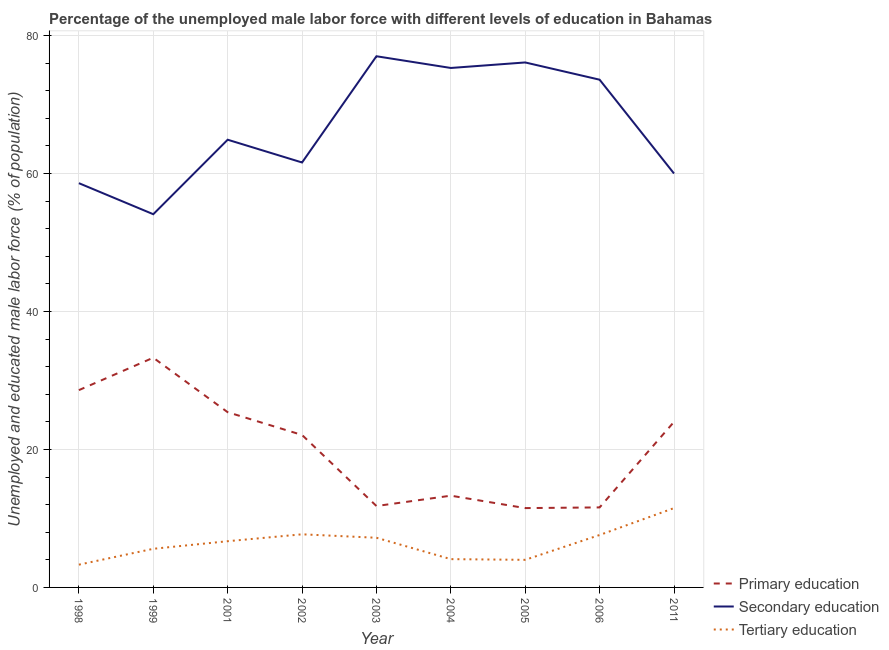How many different coloured lines are there?
Make the answer very short. 3. Does the line corresponding to percentage of male labor force who received secondary education intersect with the line corresponding to percentage of male labor force who received tertiary education?
Make the answer very short. No. Is the number of lines equal to the number of legend labels?
Provide a short and direct response. Yes. What is the percentage of male labor force who received tertiary education in 1998?
Ensure brevity in your answer.  3.3. Across all years, what is the minimum percentage of male labor force who received secondary education?
Your answer should be very brief. 54.1. In which year was the percentage of male labor force who received primary education maximum?
Your answer should be very brief. 1999. What is the total percentage of male labor force who received tertiary education in the graph?
Offer a very short reply. 57.7. What is the difference between the percentage of male labor force who received primary education in 2001 and that in 2002?
Ensure brevity in your answer.  3.3. What is the difference between the percentage of male labor force who received tertiary education in 2003 and the percentage of male labor force who received primary education in 1998?
Your response must be concise. -21.4. What is the average percentage of male labor force who received primary education per year?
Offer a very short reply. 20.18. In the year 2006, what is the difference between the percentage of male labor force who received tertiary education and percentage of male labor force who received secondary education?
Keep it short and to the point. -66. What is the ratio of the percentage of male labor force who received secondary education in 1999 to that in 2003?
Offer a very short reply. 0.7. What is the difference between the highest and the second highest percentage of male labor force who received secondary education?
Provide a succinct answer. 0.9. What is the difference between the highest and the lowest percentage of male labor force who received tertiary education?
Your answer should be very brief. 8.2. In how many years, is the percentage of male labor force who received secondary education greater than the average percentage of male labor force who received secondary education taken over all years?
Your answer should be very brief. 4. Is the sum of the percentage of male labor force who received primary education in 2004 and 2005 greater than the maximum percentage of male labor force who received tertiary education across all years?
Provide a succinct answer. Yes. Is it the case that in every year, the sum of the percentage of male labor force who received primary education and percentage of male labor force who received secondary education is greater than the percentage of male labor force who received tertiary education?
Offer a terse response. Yes. Does the percentage of male labor force who received secondary education monotonically increase over the years?
Provide a succinct answer. No. Is the percentage of male labor force who received tertiary education strictly less than the percentage of male labor force who received secondary education over the years?
Offer a very short reply. Yes. How many lines are there?
Provide a short and direct response. 3. How many years are there in the graph?
Give a very brief answer. 9. Are the values on the major ticks of Y-axis written in scientific E-notation?
Provide a short and direct response. No. Does the graph contain grids?
Give a very brief answer. Yes. Where does the legend appear in the graph?
Offer a terse response. Bottom right. How many legend labels are there?
Keep it short and to the point. 3. How are the legend labels stacked?
Offer a very short reply. Vertical. What is the title of the graph?
Offer a terse response. Percentage of the unemployed male labor force with different levels of education in Bahamas. What is the label or title of the Y-axis?
Keep it short and to the point. Unemployed and educated male labor force (% of population). What is the Unemployed and educated male labor force (% of population) in Primary education in 1998?
Provide a succinct answer. 28.6. What is the Unemployed and educated male labor force (% of population) in Secondary education in 1998?
Your answer should be compact. 58.6. What is the Unemployed and educated male labor force (% of population) of Tertiary education in 1998?
Your response must be concise. 3.3. What is the Unemployed and educated male labor force (% of population) in Primary education in 1999?
Your answer should be very brief. 33.3. What is the Unemployed and educated male labor force (% of population) of Secondary education in 1999?
Give a very brief answer. 54.1. What is the Unemployed and educated male labor force (% of population) of Tertiary education in 1999?
Your answer should be very brief. 5.6. What is the Unemployed and educated male labor force (% of population) in Primary education in 2001?
Keep it short and to the point. 25.4. What is the Unemployed and educated male labor force (% of population) of Secondary education in 2001?
Offer a terse response. 64.9. What is the Unemployed and educated male labor force (% of population) in Tertiary education in 2001?
Offer a very short reply. 6.7. What is the Unemployed and educated male labor force (% of population) in Primary education in 2002?
Your answer should be very brief. 22.1. What is the Unemployed and educated male labor force (% of population) in Secondary education in 2002?
Keep it short and to the point. 61.6. What is the Unemployed and educated male labor force (% of population) in Tertiary education in 2002?
Keep it short and to the point. 7.7. What is the Unemployed and educated male labor force (% of population) of Primary education in 2003?
Ensure brevity in your answer.  11.8. What is the Unemployed and educated male labor force (% of population) in Tertiary education in 2003?
Keep it short and to the point. 7.2. What is the Unemployed and educated male labor force (% of population) of Primary education in 2004?
Offer a very short reply. 13.3. What is the Unemployed and educated male labor force (% of population) in Secondary education in 2004?
Keep it short and to the point. 75.3. What is the Unemployed and educated male labor force (% of population) in Tertiary education in 2004?
Offer a terse response. 4.1. What is the Unemployed and educated male labor force (% of population) in Secondary education in 2005?
Your response must be concise. 76.1. What is the Unemployed and educated male labor force (% of population) in Tertiary education in 2005?
Make the answer very short. 4. What is the Unemployed and educated male labor force (% of population) in Primary education in 2006?
Make the answer very short. 11.6. What is the Unemployed and educated male labor force (% of population) of Secondary education in 2006?
Offer a very short reply. 73.6. What is the Unemployed and educated male labor force (% of population) in Tertiary education in 2006?
Give a very brief answer. 7.6. What is the Unemployed and educated male labor force (% of population) of Primary education in 2011?
Offer a terse response. 24. What is the Unemployed and educated male labor force (% of population) of Secondary education in 2011?
Your response must be concise. 60. What is the Unemployed and educated male labor force (% of population) in Tertiary education in 2011?
Ensure brevity in your answer.  11.5. Across all years, what is the maximum Unemployed and educated male labor force (% of population) in Primary education?
Provide a succinct answer. 33.3. Across all years, what is the minimum Unemployed and educated male labor force (% of population) of Secondary education?
Provide a short and direct response. 54.1. Across all years, what is the minimum Unemployed and educated male labor force (% of population) of Tertiary education?
Give a very brief answer. 3.3. What is the total Unemployed and educated male labor force (% of population) of Primary education in the graph?
Your answer should be compact. 181.6. What is the total Unemployed and educated male labor force (% of population) of Secondary education in the graph?
Keep it short and to the point. 601.2. What is the total Unemployed and educated male labor force (% of population) in Tertiary education in the graph?
Provide a succinct answer. 57.7. What is the difference between the Unemployed and educated male labor force (% of population) of Tertiary education in 1998 and that in 1999?
Your answer should be very brief. -2.3. What is the difference between the Unemployed and educated male labor force (% of population) in Primary education in 1998 and that in 2001?
Ensure brevity in your answer.  3.2. What is the difference between the Unemployed and educated male labor force (% of population) in Secondary education in 1998 and that in 2001?
Offer a very short reply. -6.3. What is the difference between the Unemployed and educated male labor force (% of population) in Primary education in 1998 and that in 2002?
Provide a succinct answer. 6.5. What is the difference between the Unemployed and educated male labor force (% of population) in Primary education in 1998 and that in 2003?
Provide a succinct answer. 16.8. What is the difference between the Unemployed and educated male labor force (% of population) in Secondary education in 1998 and that in 2003?
Give a very brief answer. -18.4. What is the difference between the Unemployed and educated male labor force (% of population) in Tertiary education in 1998 and that in 2003?
Give a very brief answer. -3.9. What is the difference between the Unemployed and educated male labor force (% of population) in Primary education in 1998 and that in 2004?
Your response must be concise. 15.3. What is the difference between the Unemployed and educated male labor force (% of population) in Secondary education in 1998 and that in 2004?
Ensure brevity in your answer.  -16.7. What is the difference between the Unemployed and educated male labor force (% of population) of Secondary education in 1998 and that in 2005?
Your response must be concise. -17.5. What is the difference between the Unemployed and educated male labor force (% of population) in Tertiary education in 1998 and that in 2006?
Your answer should be compact. -4.3. What is the difference between the Unemployed and educated male labor force (% of population) of Secondary education in 1998 and that in 2011?
Provide a succinct answer. -1.4. What is the difference between the Unemployed and educated male labor force (% of population) of Tertiary education in 1998 and that in 2011?
Your answer should be very brief. -8.2. What is the difference between the Unemployed and educated male labor force (% of population) of Secondary education in 1999 and that in 2001?
Provide a succinct answer. -10.8. What is the difference between the Unemployed and educated male labor force (% of population) of Tertiary education in 1999 and that in 2001?
Your answer should be compact. -1.1. What is the difference between the Unemployed and educated male labor force (% of population) of Tertiary education in 1999 and that in 2002?
Make the answer very short. -2.1. What is the difference between the Unemployed and educated male labor force (% of population) of Secondary education in 1999 and that in 2003?
Your answer should be very brief. -22.9. What is the difference between the Unemployed and educated male labor force (% of population) in Tertiary education in 1999 and that in 2003?
Offer a terse response. -1.6. What is the difference between the Unemployed and educated male labor force (% of population) of Primary education in 1999 and that in 2004?
Give a very brief answer. 20. What is the difference between the Unemployed and educated male labor force (% of population) in Secondary education in 1999 and that in 2004?
Your answer should be very brief. -21.2. What is the difference between the Unemployed and educated male labor force (% of population) in Primary education in 1999 and that in 2005?
Your answer should be compact. 21.8. What is the difference between the Unemployed and educated male labor force (% of population) of Secondary education in 1999 and that in 2005?
Make the answer very short. -22. What is the difference between the Unemployed and educated male labor force (% of population) of Tertiary education in 1999 and that in 2005?
Offer a terse response. 1.6. What is the difference between the Unemployed and educated male labor force (% of population) in Primary education in 1999 and that in 2006?
Keep it short and to the point. 21.7. What is the difference between the Unemployed and educated male labor force (% of population) of Secondary education in 1999 and that in 2006?
Your answer should be compact. -19.5. What is the difference between the Unemployed and educated male labor force (% of population) of Secondary education in 1999 and that in 2011?
Make the answer very short. -5.9. What is the difference between the Unemployed and educated male labor force (% of population) in Primary education in 2001 and that in 2002?
Keep it short and to the point. 3.3. What is the difference between the Unemployed and educated male labor force (% of population) of Secondary education in 2001 and that in 2002?
Make the answer very short. 3.3. What is the difference between the Unemployed and educated male labor force (% of population) in Tertiary education in 2001 and that in 2002?
Offer a terse response. -1. What is the difference between the Unemployed and educated male labor force (% of population) in Tertiary education in 2001 and that in 2003?
Offer a terse response. -0.5. What is the difference between the Unemployed and educated male labor force (% of population) in Secondary education in 2001 and that in 2005?
Give a very brief answer. -11.2. What is the difference between the Unemployed and educated male labor force (% of population) of Primary education in 2001 and that in 2006?
Ensure brevity in your answer.  13.8. What is the difference between the Unemployed and educated male labor force (% of population) of Secondary education in 2001 and that in 2006?
Offer a terse response. -8.7. What is the difference between the Unemployed and educated male labor force (% of population) of Primary education in 2001 and that in 2011?
Give a very brief answer. 1.4. What is the difference between the Unemployed and educated male labor force (% of population) in Tertiary education in 2001 and that in 2011?
Ensure brevity in your answer.  -4.8. What is the difference between the Unemployed and educated male labor force (% of population) in Primary education in 2002 and that in 2003?
Ensure brevity in your answer.  10.3. What is the difference between the Unemployed and educated male labor force (% of population) in Secondary education in 2002 and that in 2003?
Offer a very short reply. -15.4. What is the difference between the Unemployed and educated male labor force (% of population) of Secondary education in 2002 and that in 2004?
Make the answer very short. -13.7. What is the difference between the Unemployed and educated male labor force (% of population) of Tertiary education in 2002 and that in 2004?
Your response must be concise. 3.6. What is the difference between the Unemployed and educated male labor force (% of population) in Primary education in 2002 and that in 2005?
Offer a terse response. 10.6. What is the difference between the Unemployed and educated male labor force (% of population) of Tertiary education in 2002 and that in 2005?
Your response must be concise. 3.7. What is the difference between the Unemployed and educated male labor force (% of population) in Primary education in 2002 and that in 2011?
Your answer should be very brief. -1.9. What is the difference between the Unemployed and educated male labor force (% of population) in Tertiary education in 2002 and that in 2011?
Your answer should be very brief. -3.8. What is the difference between the Unemployed and educated male labor force (% of population) of Tertiary education in 2003 and that in 2004?
Offer a very short reply. 3.1. What is the difference between the Unemployed and educated male labor force (% of population) of Primary education in 2003 and that in 2005?
Your response must be concise. 0.3. What is the difference between the Unemployed and educated male labor force (% of population) of Secondary education in 2003 and that in 2005?
Provide a succinct answer. 0.9. What is the difference between the Unemployed and educated male labor force (% of population) of Tertiary education in 2003 and that in 2005?
Provide a short and direct response. 3.2. What is the difference between the Unemployed and educated male labor force (% of population) in Primary education in 2003 and that in 2011?
Provide a short and direct response. -12.2. What is the difference between the Unemployed and educated male labor force (% of population) in Primary education in 2004 and that in 2005?
Offer a very short reply. 1.8. What is the difference between the Unemployed and educated male labor force (% of population) in Secondary education in 2004 and that in 2005?
Your answer should be compact. -0.8. What is the difference between the Unemployed and educated male labor force (% of population) of Tertiary education in 2004 and that in 2005?
Keep it short and to the point. 0.1. What is the difference between the Unemployed and educated male labor force (% of population) of Secondary education in 2004 and that in 2006?
Provide a short and direct response. 1.7. What is the difference between the Unemployed and educated male labor force (% of population) in Tertiary education in 2004 and that in 2006?
Offer a terse response. -3.5. What is the difference between the Unemployed and educated male labor force (% of population) in Secondary education in 2004 and that in 2011?
Your answer should be very brief. 15.3. What is the difference between the Unemployed and educated male labor force (% of population) in Tertiary education in 2004 and that in 2011?
Provide a short and direct response. -7.4. What is the difference between the Unemployed and educated male labor force (% of population) of Primary education in 2005 and that in 2006?
Offer a very short reply. -0.1. What is the difference between the Unemployed and educated male labor force (% of population) of Tertiary education in 2005 and that in 2006?
Your response must be concise. -3.6. What is the difference between the Unemployed and educated male labor force (% of population) in Secondary education in 2006 and that in 2011?
Your answer should be compact. 13.6. What is the difference between the Unemployed and educated male labor force (% of population) of Tertiary education in 2006 and that in 2011?
Your answer should be compact. -3.9. What is the difference between the Unemployed and educated male labor force (% of population) of Primary education in 1998 and the Unemployed and educated male labor force (% of population) of Secondary education in 1999?
Keep it short and to the point. -25.5. What is the difference between the Unemployed and educated male labor force (% of population) in Primary education in 1998 and the Unemployed and educated male labor force (% of population) in Secondary education in 2001?
Make the answer very short. -36.3. What is the difference between the Unemployed and educated male labor force (% of population) in Primary education in 1998 and the Unemployed and educated male labor force (% of population) in Tertiary education in 2001?
Your answer should be compact. 21.9. What is the difference between the Unemployed and educated male labor force (% of population) in Secondary education in 1998 and the Unemployed and educated male labor force (% of population) in Tertiary education in 2001?
Offer a terse response. 51.9. What is the difference between the Unemployed and educated male labor force (% of population) of Primary education in 1998 and the Unemployed and educated male labor force (% of population) of Secondary education in 2002?
Provide a succinct answer. -33. What is the difference between the Unemployed and educated male labor force (% of population) in Primary education in 1998 and the Unemployed and educated male labor force (% of population) in Tertiary education in 2002?
Ensure brevity in your answer.  20.9. What is the difference between the Unemployed and educated male labor force (% of population) of Secondary education in 1998 and the Unemployed and educated male labor force (% of population) of Tertiary education in 2002?
Ensure brevity in your answer.  50.9. What is the difference between the Unemployed and educated male labor force (% of population) in Primary education in 1998 and the Unemployed and educated male labor force (% of population) in Secondary education in 2003?
Provide a short and direct response. -48.4. What is the difference between the Unemployed and educated male labor force (% of population) of Primary education in 1998 and the Unemployed and educated male labor force (% of population) of Tertiary education in 2003?
Ensure brevity in your answer.  21.4. What is the difference between the Unemployed and educated male labor force (% of population) of Secondary education in 1998 and the Unemployed and educated male labor force (% of population) of Tertiary education in 2003?
Your answer should be very brief. 51.4. What is the difference between the Unemployed and educated male labor force (% of population) of Primary education in 1998 and the Unemployed and educated male labor force (% of population) of Secondary education in 2004?
Your answer should be compact. -46.7. What is the difference between the Unemployed and educated male labor force (% of population) of Primary education in 1998 and the Unemployed and educated male labor force (% of population) of Tertiary education in 2004?
Keep it short and to the point. 24.5. What is the difference between the Unemployed and educated male labor force (% of population) of Secondary education in 1998 and the Unemployed and educated male labor force (% of population) of Tertiary education in 2004?
Offer a very short reply. 54.5. What is the difference between the Unemployed and educated male labor force (% of population) of Primary education in 1998 and the Unemployed and educated male labor force (% of population) of Secondary education in 2005?
Your answer should be compact. -47.5. What is the difference between the Unemployed and educated male labor force (% of population) of Primary education in 1998 and the Unemployed and educated male labor force (% of population) of Tertiary education in 2005?
Your response must be concise. 24.6. What is the difference between the Unemployed and educated male labor force (% of population) of Secondary education in 1998 and the Unemployed and educated male labor force (% of population) of Tertiary education in 2005?
Your response must be concise. 54.6. What is the difference between the Unemployed and educated male labor force (% of population) of Primary education in 1998 and the Unemployed and educated male labor force (% of population) of Secondary education in 2006?
Provide a short and direct response. -45. What is the difference between the Unemployed and educated male labor force (% of population) of Secondary education in 1998 and the Unemployed and educated male labor force (% of population) of Tertiary education in 2006?
Make the answer very short. 51. What is the difference between the Unemployed and educated male labor force (% of population) of Primary education in 1998 and the Unemployed and educated male labor force (% of population) of Secondary education in 2011?
Provide a succinct answer. -31.4. What is the difference between the Unemployed and educated male labor force (% of population) in Secondary education in 1998 and the Unemployed and educated male labor force (% of population) in Tertiary education in 2011?
Keep it short and to the point. 47.1. What is the difference between the Unemployed and educated male labor force (% of population) in Primary education in 1999 and the Unemployed and educated male labor force (% of population) in Secondary education in 2001?
Make the answer very short. -31.6. What is the difference between the Unemployed and educated male labor force (% of population) of Primary education in 1999 and the Unemployed and educated male labor force (% of population) of Tertiary education in 2001?
Offer a very short reply. 26.6. What is the difference between the Unemployed and educated male labor force (% of population) in Secondary education in 1999 and the Unemployed and educated male labor force (% of population) in Tertiary education in 2001?
Your response must be concise. 47.4. What is the difference between the Unemployed and educated male labor force (% of population) in Primary education in 1999 and the Unemployed and educated male labor force (% of population) in Secondary education in 2002?
Provide a short and direct response. -28.3. What is the difference between the Unemployed and educated male labor force (% of population) of Primary education in 1999 and the Unemployed and educated male labor force (% of population) of Tertiary education in 2002?
Provide a short and direct response. 25.6. What is the difference between the Unemployed and educated male labor force (% of population) in Secondary education in 1999 and the Unemployed and educated male labor force (% of population) in Tertiary education in 2002?
Keep it short and to the point. 46.4. What is the difference between the Unemployed and educated male labor force (% of population) in Primary education in 1999 and the Unemployed and educated male labor force (% of population) in Secondary education in 2003?
Offer a terse response. -43.7. What is the difference between the Unemployed and educated male labor force (% of population) of Primary education in 1999 and the Unemployed and educated male labor force (% of population) of Tertiary education in 2003?
Ensure brevity in your answer.  26.1. What is the difference between the Unemployed and educated male labor force (% of population) in Secondary education in 1999 and the Unemployed and educated male labor force (% of population) in Tertiary education in 2003?
Offer a terse response. 46.9. What is the difference between the Unemployed and educated male labor force (% of population) of Primary education in 1999 and the Unemployed and educated male labor force (% of population) of Secondary education in 2004?
Keep it short and to the point. -42. What is the difference between the Unemployed and educated male labor force (% of population) of Primary education in 1999 and the Unemployed and educated male labor force (% of population) of Tertiary education in 2004?
Give a very brief answer. 29.2. What is the difference between the Unemployed and educated male labor force (% of population) in Secondary education in 1999 and the Unemployed and educated male labor force (% of population) in Tertiary education in 2004?
Your answer should be very brief. 50. What is the difference between the Unemployed and educated male labor force (% of population) of Primary education in 1999 and the Unemployed and educated male labor force (% of population) of Secondary education in 2005?
Your response must be concise. -42.8. What is the difference between the Unemployed and educated male labor force (% of population) in Primary education in 1999 and the Unemployed and educated male labor force (% of population) in Tertiary education in 2005?
Your answer should be very brief. 29.3. What is the difference between the Unemployed and educated male labor force (% of population) of Secondary education in 1999 and the Unemployed and educated male labor force (% of population) of Tertiary education in 2005?
Your response must be concise. 50.1. What is the difference between the Unemployed and educated male labor force (% of population) in Primary education in 1999 and the Unemployed and educated male labor force (% of population) in Secondary education in 2006?
Your response must be concise. -40.3. What is the difference between the Unemployed and educated male labor force (% of population) of Primary education in 1999 and the Unemployed and educated male labor force (% of population) of Tertiary education in 2006?
Your answer should be very brief. 25.7. What is the difference between the Unemployed and educated male labor force (% of population) of Secondary education in 1999 and the Unemployed and educated male labor force (% of population) of Tertiary education in 2006?
Keep it short and to the point. 46.5. What is the difference between the Unemployed and educated male labor force (% of population) of Primary education in 1999 and the Unemployed and educated male labor force (% of population) of Secondary education in 2011?
Give a very brief answer. -26.7. What is the difference between the Unemployed and educated male labor force (% of population) in Primary education in 1999 and the Unemployed and educated male labor force (% of population) in Tertiary education in 2011?
Your response must be concise. 21.8. What is the difference between the Unemployed and educated male labor force (% of population) in Secondary education in 1999 and the Unemployed and educated male labor force (% of population) in Tertiary education in 2011?
Provide a succinct answer. 42.6. What is the difference between the Unemployed and educated male labor force (% of population) in Primary education in 2001 and the Unemployed and educated male labor force (% of population) in Secondary education in 2002?
Provide a succinct answer. -36.2. What is the difference between the Unemployed and educated male labor force (% of population) in Primary education in 2001 and the Unemployed and educated male labor force (% of population) in Tertiary education in 2002?
Your response must be concise. 17.7. What is the difference between the Unemployed and educated male labor force (% of population) of Secondary education in 2001 and the Unemployed and educated male labor force (% of population) of Tertiary education in 2002?
Provide a short and direct response. 57.2. What is the difference between the Unemployed and educated male labor force (% of population) in Primary education in 2001 and the Unemployed and educated male labor force (% of population) in Secondary education in 2003?
Your answer should be compact. -51.6. What is the difference between the Unemployed and educated male labor force (% of population) in Primary education in 2001 and the Unemployed and educated male labor force (% of population) in Tertiary education in 2003?
Your answer should be very brief. 18.2. What is the difference between the Unemployed and educated male labor force (% of population) in Secondary education in 2001 and the Unemployed and educated male labor force (% of population) in Tertiary education in 2003?
Your answer should be compact. 57.7. What is the difference between the Unemployed and educated male labor force (% of population) in Primary education in 2001 and the Unemployed and educated male labor force (% of population) in Secondary education in 2004?
Ensure brevity in your answer.  -49.9. What is the difference between the Unemployed and educated male labor force (% of population) in Primary education in 2001 and the Unemployed and educated male labor force (% of population) in Tertiary education in 2004?
Your response must be concise. 21.3. What is the difference between the Unemployed and educated male labor force (% of population) of Secondary education in 2001 and the Unemployed and educated male labor force (% of population) of Tertiary education in 2004?
Give a very brief answer. 60.8. What is the difference between the Unemployed and educated male labor force (% of population) in Primary education in 2001 and the Unemployed and educated male labor force (% of population) in Secondary education in 2005?
Provide a short and direct response. -50.7. What is the difference between the Unemployed and educated male labor force (% of population) in Primary education in 2001 and the Unemployed and educated male labor force (% of population) in Tertiary education in 2005?
Make the answer very short. 21.4. What is the difference between the Unemployed and educated male labor force (% of population) in Secondary education in 2001 and the Unemployed and educated male labor force (% of population) in Tertiary education in 2005?
Your answer should be very brief. 60.9. What is the difference between the Unemployed and educated male labor force (% of population) of Primary education in 2001 and the Unemployed and educated male labor force (% of population) of Secondary education in 2006?
Offer a terse response. -48.2. What is the difference between the Unemployed and educated male labor force (% of population) in Secondary education in 2001 and the Unemployed and educated male labor force (% of population) in Tertiary education in 2006?
Offer a very short reply. 57.3. What is the difference between the Unemployed and educated male labor force (% of population) of Primary education in 2001 and the Unemployed and educated male labor force (% of population) of Secondary education in 2011?
Offer a very short reply. -34.6. What is the difference between the Unemployed and educated male labor force (% of population) in Primary education in 2001 and the Unemployed and educated male labor force (% of population) in Tertiary education in 2011?
Give a very brief answer. 13.9. What is the difference between the Unemployed and educated male labor force (% of population) in Secondary education in 2001 and the Unemployed and educated male labor force (% of population) in Tertiary education in 2011?
Provide a short and direct response. 53.4. What is the difference between the Unemployed and educated male labor force (% of population) of Primary education in 2002 and the Unemployed and educated male labor force (% of population) of Secondary education in 2003?
Your answer should be very brief. -54.9. What is the difference between the Unemployed and educated male labor force (% of population) of Primary education in 2002 and the Unemployed and educated male labor force (% of population) of Tertiary education in 2003?
Make the answer very short. 14.9. What is the difference between the Unemployed and educated male labor force (% of population) in Secondary education in 2002 and the Unemployed and educated male labor force (% of population) in Tertiary education in 2003?
Provide a succinct answer. 54.4. What is the difference between the Unemployed and educated male labor force (% of population) of Primary education in 2002 and the Unemployed and educated male labor force (% of population) of Secondary education in 2004?
Your response must be concise. -53.2. What is the difference between the Unemployed and educated male labor force (% of population) of Secondary education in 2002 and the Unemployed and educated male labor force (% of population) of Tertiary education in 2004?
Your answer should be very brief. 57.5. What is the difference between the Unemployed and educated male labor force (% of population) of Primary education in 2002 and the Unemployed and educated male labor force (% of population) of Secondary education in 2005?
Provide a succinct answer. -54. What is the difference between the Unemployed and educated male labor force (% of population) of Primary education in 2002 and the Unemployed and educated male labor force (% of population) of Tertiary education in 2005?
Your answer should be compact. 18.1. What is the difference between the Unemployed and educated male labor force (% of population) of Secondary education in 2002 and the Unemployed and educated male labor force (% of population) of Tertiary education in 2005?
Give a very brief answer. 57.6. What is the difference between the Unemployed and educated male labor force (% of population) in Primary education in 2002 and the Unemployed and educated male labor force (% of population) in Secondary education in 2006?
Ensure brevity in your answer.  -51.5. What is the difference between the Unemployed and educated male labor force (% of population) in Secondary education in 2002 and the Unemployed and educated male labor force (% of population) in Tertiary education in 2006?
Keep it short and to the point. 54. What is the difference between the Unemployed and educated male labor force (% of population) of Primary education in 2002 and the Unemployed and educated male labor force (% of population) of Secondary education in 2011?
Your answer should be compact. -37.9. What is the difference between the Unemployed and educated male labor force (% of population) in Primary education in 2002 and the Unemployed and educated male labor force (% of population) in Tertiary education in 2011?
Ensure brevity in your answer.  10.6. What is the difference between the Unemployed and educated male labor force (% of population) in Secondary education in 2002 and the Unemployed and educated male labor force (% of population) in Tertiary education in 2011?
Your answer should be very brief. 50.1. What is the difference between the Unemployed and educated male labor force (% of population) of Primary education in 2003 and the Unemployed and educated male labor force (% of population) of Secondary education in 2004?
Provide a short and direct response. -63.5. What is the difference between the Unemployed and educated male labor force (% of population) in Primary education in 2003 and the Unemployed and educated male labor force (% of population) in Tertiary education in 2004?
Ensure brevity in your answer.  7.7. What is the difference between the Unemployed and educated male labor force (% of population) in Secondary education in 2003 and the Unemployed and educated male labor force (% of population) in Tertiary education in 2004?
Provide a succinct answer. 72.9. What is the difference between the Unemployed and educated male labor force (% of population) in Primary education in 2003 and the Unemployed and educated male labor force (% of population) in Secondary education in 2005?
Provide a short and direct response. -64.3. What is the difference between the Unemployed and educated male labor force (% of population) of Primary education in 2003 and the Unemployed and educated male labor force (% of population) of Tertiary education in 2005?
Offer a very short reply. 7.8. What is the difference between the Unemployed and educated male labor force (% of population) in Secondary education in 2003 and the Unemployed and educated male labor force (% of population) in Tertiary education in 2005?
Keep it short and to the point. 73. What is the difference between the Unemployed and educated male labor force (% of population) in Primary education in 2003 and the Unemployed and educated male labor force (% of population) in Secondary education in 2006?
Keep it short and to the point. -61.8. What is the difference between the Unemployed and educated male labor force (% of population) in Primary education in 2003 and the Unemployed and educated male labor force (% of population) in Tertiary education in 2006?
Give a very brief answer. 4.2. What is the difference between the Unemployed and educated male labor force (% of population) of Secondary education in 2003 and the Unemployed and educated male labor force (% of population) of Tertiary education in 2006?
Provide a succinct answer. 69.4. What is the difference between the Unemployed and educated male labor force (% of population) of Primary education in 2003 and the Unemployed and educated male labor force (% of population) of Secondary education in 2011?
Your answer should be compact. -48.2. What is the difference between the Unemployed and educated male labor force (% of population) of Primary education in 2003 and the Unemployed and educated male labor force (% of population) of Tertiary education in 2011?
Offer a terse response. 0.3. What is the difference between the Unemployed and educated male labor force (% of population) of Secondary education in 2003 and the Unemployed and educated male labor force (% of population) of Tertiary education in 2011?
Offer a very short reply. 65.5. What is the difference between the Unemployed and educated male labor force (% of population) in Primary education in 2004 and the Unemployed and educated male labor force (% of population) in Secondary education in 2005?
Your answer should be compact. -62.8. What is the difference between the Unemployed and educated male labor force (% of population) of Secondary education in 2004 and the Unemployed and educated male labor force (% of population) of Tertiary education in 2005?
Offer a terse response. 71.3. What is the difference between the Unemployed and educated male labor force (% of population) of Primary education in 2004 and the Unemployed and educated male labor force (% of population) of Secondary education in 2006?
Your answer should be compact. -60.3. What is the difference between the Unemployed and educated male labor force (% of population) in Secondary education in 2004 and the Unemployed and educated male labor force (% of population) in Tertiary education in 2006?
Offer a terse response. 67.7. What is the difference between the Unemployed and educated male labor force (% of population) in Primary education in 2004 and the Unemployed and educated male labor force (% of population) in Secondary education in 2011?
Keep it short and to the point. -46.7. What is the difference between the Unemployed and educated male labor force (% of population) of Primary education in 2004 and the Unemployed and educated male labor force (% of population) of Tertiary education in 2011?
Provide a short and direct response. 1.8. What is the difference between the Unemployed and educated male labor force (% of population) of Secondary education in 2004 and the Unemployed and educated male labor force (% of population) of Tertiary education in 2011?
Provide a short and direct response. 63.8. What is the difference between the Unemployed and educated male labor force (% of population) of Primary education in 2005 and the Unemployed and educated male labor force (% of population) of Secondary education in 2006?
Your response must be concise. -62.1. What is the difference between the Unemployed and educated male labor force (% of population) in Secondary education in 2005 and the Unemployed and educated male labor force (% of population) in Tertiary education in 2006?
Keep it short and to the point. 68.5. What is the difference between the Unemployed and educated male labor force (% of population) of Primary education in 2005 and the Unemployed and educated male labor force (% of population) of Secondary education in 2011?
Provide a succinct answer. -48.5. What is the difference between the Unemployed and educated male labor force (% of population) of Secondary education in 2005 and the Unemployed and educated male labor force (% of population) of Tertiary education in 2011?
Ensure brevity in your answer.  64.6. What is the difference between the Unemployed and educated male labor force (% of population) in Primary education in 2006 and the Unemployed and educated male labor force (% of population) in Secondary education in 2011?
Keep it short and to the point. -48.4. What is the difference between the Unemployed and educated male labor force (% of population) in Secondary education in 2006 and the Unemployed and educated male labor force (% of population) in Tertiary education in 2011?
Your answer should be very brief. 62.1. What is the average Unemployed and educated male labor force (% of population) of Primary education per year?
Keep it short and to the point. 20.18. What is the average Unemployed and educated male labor force (% of population) of Secondary education per year?
Ensure brevity in your answer.  66.8. What is the average Unemployed and educated male labor force (% of population) in Tertiary education per year?
Your answer should be compact. 6.41. In the year 1998, what is the difference between the Unemployed and educated male labor force (% of population) in Primary education and Unemployed and educated male labor force (% of population) in Tertiary education?
Keep it short and to the point. 25.3. In the year 1998, what is the difference between the Unemployed and educated male labor force (% of population) in Secondary education and Unemployed and educated male labor force (% of population) in Tertiary education?
Give a very brief answer. 55.3. In the year 1999, what is the difference between the Unemployed and educated male labor force (% of population) in Primary education and Unemployed and educated male labor force (% of population) in Secondary education?
Provide a succinct answer. -20.8. In the year 1999, what is the difference between the Unemployed and educated male labor force (% of population) of Primary education and Unemployed and educated male labor force (% of population) of Tertiary education?
Provide a succinct answer. 27.7. In the year 1999, what is the difference between the Unemployed and educated male labor force (% of population) in Secondary education and Unemployed and educated male labor force (% of population) in Tertiary education?
Keep it short and to the point. 48.5. In the year 2001, what is the difference between the Unemployed and educated male labor force (% of population) of Primary education and Unemployed and educated male labor force (% of population) of Secondary education?
Make the answer very short. -39.5. In the year 2001, what is the difference between the Unemployed and educated male labor force (% of population) in Primary education and Unemployed and educated male labor force (% of population) in Tertiary education?
Keep it short and to the point. 18.7. In the year 2001, what is the difference between the Unemployed and educated male labor force (% of population) of Secondary education and Unemployed and educated male labor force (% of population) of Tertiary education?
Provide a succinct answer. 58.2. In the year 2002, what is the difference between the Unemployed and educated male labor force (% of population) of Primary education and Unemployed and educated male labor force (% of population) of Secondary education?
Ensure brevity in your answer.  -39.5. In the year 2002, what is the difference between the Unemployed and educated male labor force (% of population) in Secondary education and Unemployed and educated male labor force (% of population) in Tertiary education?
Give a very brief answer. 53.9. In the year 2003, what is the difference between the Unemployed and educated male labor force (% of population) in Primary education and Unemployed and educated male labor force (% of population) in Secondary education?
Provide a succinct answer. -65.2. In the year 2003, what is the difference between the Unemployed and educated male labor force (% of population) in Primary education and Unemployed and educated male labor force (% of population) in Tertiary education?
Ensure brevity in your answer.  4.6. In the year 2003, what is the difference between the Unemployed and educated male labor force (% of population) of Secondary education and Unemployed and educated male labor force (% of population) of Tertiary education?
Offer a very short reply. 69.8. In the year 2004, what is the difference between the Unemployed and educated male labor force (% of population) of Primary education and Unemployed and educated male labor force (% of population) of Secondary education?
Ensure brevity in your answer.  -62. In the year 2004, what is the difference between the Unemployed and educated male labor force (% of population) of Primary education and Unemployed and educated male labor force (% of population) of Tertiary education?
Your answer should be very brief. 9.2. In the year 2004, what is the difference between the Unemployed and educated male labor force (% of population) in Secondary education and Unemployed and educated male labor force (% of population) in Tertiary education?
Provide a short and direct response. 71.2. In the year 2005, what is the difference between the Unemployed and educated male labor force (% of population) of Primary education and Unemployed and educated male labor force (% of population) of Secondary education?
Your answer should be compact. -64.6. In the year 2005, what is the difference between the Unemployed and educated male labor force (% of population) in Primary education and Unemployed and educated male labor force (% of population) in Tertiary education?
Offer a very short reply. 7.5. In the year 2005, what is the difference between the Unemployed and educated male labor force (% of population) of Secondary education and Unemployed and educated male labor force (% of population) of Tertiary education?
Your answer should be compact. 72.1. In the year 2006, what is the difference between the Unemployed and educated male labor force (% of population) of Primary education and Unemployed and educated male labor force (% of population) of Secondary education?
Your answer should be very brief. -62. In the year 2011, what is the difference between the Unemployed and educated male labor force (% of population) in Primary education and Unemployed and educated male labor force (% of population) in Secondary education?
Offer a very short reply. -36. In the year 2011, what is the difference between the Unemployed and educated male labor force (% of population) in Secondary education and Unemployed and educated male labor force (% of population) in Tertiary education?
Offer a terse response. 48.5. What is the ratio of the Unemployed and educated male labor force (% of population) in Primary education in 1998 to that in 1999?
Your response must be concise. 0.86. What is the ratio of the Unemployed and educated male labor force (% of population) of Secondary education in 1998 to that in 1999?
Provide a short and direct response. 1.08. What is the ratio of the Unemployed and educated male labor force (% of population) in Tertiary education in 1998 to that in 1999?
Provide a short and direct response. 0.59. What is the ratio of the Unemployed and educated male labor force (% of population) in Primary education in 1998 to that in 2001?
Make the answer very short. 1.13. What is the ratio of the Unemployed and educated male labor force (% of population) in Secondary education in 1998 to that in 2001?
Your answer should be compact. 0.9. What is the ratio of the Unemployed and educated male labor force (% of population) in Tertiary education in 1998 to that in 2001?
Offer a very short reply. 0.49. What is the ratio of the Unemployed and educated male labor force (% of population) of Primary education in 1998 to that in 2002?
Provide a succinct answer. 1.29. What is the ratio of the Unemployed and educated male labor force (% of population) in Secondary education in 1998 to that in 2002?
Offer a terse response. 0.95. What is the ratio of the Unemployed and educated male labor force (% of population) of Tertiary education in 1998 to that in 2002?
Your answer should be compact. 0.43. What is the ratio of the Unemployed and educated male labor force (% of population) of Primary education in 1998 to that in 2003?
Offer a terse response. 2.42. What is the ratio of the Unemployed and educated male labor force (% of population) in Secondary education in 1998 to that in 2003?
Your response must be concise. 0.76. What is the ratio of the Unemployed and educated male labor force (% of population) in Tertiary education in 1998 to that in 2003?
Your answer should be very brief. 0.46. What is the ratio of the Unemployed and educated male labor force (% of population) in Primary education in 1998 to that in 2004?
Make the answer very short. 2.15. What is the ratio of the Unemployed and educated male labor force (% of population) of Secondary education in 1998 to that in 2004?
Your answer should be very brief. 0.78. What is the ratio of the Unemployed and educated male labor force (% of population) of Tertiary education in 1998 to that in 2004?
Provide a short and direct response. 0.8. What is the ratio of the Unemployed and educated male labor force (% of population) in Primary education in 1998 to that in 2005?
Give a very brief answer. 2.49. What is the ratio of the Unemployed and educated male labor force (% of population) in Secondary education in 1998 to that in 2005?
Ensure brevity in your answer.  0.77. What is the ratio of the Unemployed and educated male labor force (% of population) in Tertiary education in 1998 to that in 2005?
Offer a terse response. 0.82. What is the ratio of the Unemployed and educated male labor force (% of population) in Primary education in 1998 to that in 2006?
Ensure brevity in your answer.  2.47. What is the ratio of the Unemployed and educated male labor force (% of population) of Secondary education in 1998 to that in 2006?
Provide a short and direct response. 0.8. What is the ratio of the Unemployed and educated male labor force (% of population) in Tertiary education in 1998 to that in 2006?
Make the answer very short. 0.43. What is the ratio of the Unemployed and educated male labor force (% of population) in Primary education in 1998 to that in 2011?
Offer a very short reply. 1.19. What is the ratio of the Unemployed and educated male labor force (% of population) in Secondary education in 1998 to that in 2011?
Provide a short and direct response. 0.98. What is the ratio of the Unemployed and educated male labor force (% of population) of Tertiary education in 1998 to that in 2011?
Your answer should be very brief. 0.29. What is the ratio of the Unemployed and educated male labor force (% of population) of Primary education in 1999 to that in 2001?
Offer a terse response. 1.31. What is the ratio of the Unemployed and educated male labor force (% of population) in Secondary education in 1999 to that in 2001?
Make the answer very short. 0.83. What is the ratio of the Unemployed and educated male labor force (% of population) of Tertiary education in 1999 to that in 2001?
Give a very brief answer. 0.84. What is the ratio of the Unemployed and educated male labor force (% of population) of Primary education in 1999 to that in 2002?
Offer a terse response. 1.51. What is the ratio of the Unemployed and educated male labor force (% of population) in Secondary education in 1999 to that in 2002?
Your answer should be very brief. 0.88. What is the ratio of the Unemployed and educated male labor force (% of population) in Tertiary education in 1999 to that in 2002?
Ensure brevity in your answer.  0.73. What is the ratio of the Unemployed and educated male labor force (% of population) of Primary education in 1999 to that in 2003?
Your response must be concise. 2.82. What is the ratio of the Unemployed and educated male labor force (% of population) in Secondary education in 1999 to that in 2003?
Offer a terse response. 0.7. What is the ratio of the Unemployed and educated male labor force (% of population) of Tertiary education in 1999 to that in 2003?
Offer a terse response. 0.78. What is the ratio of the Unemployed and educated male labor force (% of population) in Primary education in 1999 to that in 2004?
Your answer should be very brief. 2.5. What is the ratio of the Unemployed and educated male labor force (% of population) of Secondary education in 1999 to that in 2004?
Offer a very short reply. 0.72. What is the ratio of the Unemployed and educated male labor force (% of population) in Tertiary education in 1999 to that in 2004?
Make the answer very short. 1.37. What is the ratio of the Unemployed and educated male labor force (% of population) in Primary education in 1999 to that in 2005?
Make the answer very short. 2.9. What is the ratio of the Unemployed and educated male labor force (% of population) in Secondary education in 1999 to that in 2005?
Offer a terse response. 0.71. What is the ratio of the Unemployed and educated male labor force (% of population) in Tertiary education in 1999 to that in 2005?
Provide a short and direct response. 1.4. What is the ratio of the Unemployed and educated male labor force (% of population) in Primary education in 1999 to that in 2006?
Provide a succinct answer. 2.87. What is the ratio of the Unemployed and educated male labor force (% of population) in Secondary education in 1999 to that in 2006?
Offer a terse response. 0.74. What is the ratio of the Unemployed and educated male labor force (% of population) of Tertiary education in 1999 to that in 2006?
Your response must be concise. 0.74. What is the ratio of the Unemployed and educated male labor force (% of population) in Primary education in 1999 to that in 2011?
Offer a terse response. 1.39. What is the ratio of the Unemployed and educated male labor force (% of population) in Secondary education in 1999 to that in 2011?
Offer a very short reply. 0.9. What is the ratio of the Unemployed and educated male labor force (% of population) of Tertiary education in 1999 to that in 2011?
Ensure brevity in your answer.  0.49. What is the ratio of the Unemployed and educated male labor force (% of population) in Primary education in 2001 to that in 2002?
Keep it short and to the point. 1.15. What is the ratio of the Unemployed and educated male labor force (% of population) in Secondary education in 2001 to that in 2002?
Provide a short and direct response. 1.05. What is the ratio of the Unemployed and educated male labor force (% of population) in Tertiary education in 2001 to that in 2002?
Your answer should be compact. 0.87. What is the ratio of the Unemployed and educated male labor force (% of population) in Primary education in 2001 to that in 2003?
Ensure brevity in your answer.  2.15. What is the ratio of the Unemployed and educated male labor force (% of population) in Secondary education in 2001 to that in 2003?
Make the answer very short. 0.84. What is the ratio of the Unemployed and educated male labor force (% of population) in Tertiary education in 2001 to that in 2003?
Offer a terse response. 0.93. What is the ratio of the Unemployed and educated male labor force (% of population) of Primary education in 2001 to that in 2004?
Provide a short and direct response. 1.91. What is the ratio of the Unemployed and educated male labor force (% of population) in Secondary education in 2001 to that in 2004?
Ensure brevity in your answer.  0.86. What is the ratio of the Unemployed and educated male labor force (% of population) of Tertiary education in 2001 to that in 2004?
Your answer should be very brief. 1.63. What is the ratio of the Unemployed and educated male labor force (% of population) in Primary education in 2001 to that in 2005?
Keep it short and to the point. 2.21. What is the ratio of the Unemployed and educated male labor force (% of population) in Secondary education in 2001 to that in 2005?
Your answer should be compact. 0.85. What is the ratio of the Unemployed and educated male labor force (% of population) of Tertiary education in 2001 to that in 2005?
Ensure brevity in your answer.  1.68. What is the ratio of the Unemployed and educated male labor force (% of population) of Primary education in 2001 to that in 2006?
Offer a terse response. 2.19. What is the ratio of the Unemployed and educated male labor force (% of population) in Secondary education in 2001 to that in 2006?
Provide a succinct answer. 0.88. What is the ratio of the Unemployed and educated male labor force (% of population) of Tertiary education in 2001 to that in 2006?
Offer a very short reply. 0.88. What is the ratio of the Unemployed and educated male labor force (% of population) in Primary education in 2001 to that in 2011?
Your answer should be very brief. 1.06. What is the ratio of the Unemployed and educated male labor force (% of population) in Secondary education in 2001 to that in 2011?
Ensure brevity in your answer.  1.08. What is the ratio of the Unemployed and educated male labor force (% of population) of Tertiary education in 2001 to that in 2011?
Ensure brevity in your answer.  0.58. What is the ratio of the Unemployed and educated male labor force (% of population) in Primary education in 2002 to that in 2003?
Provide a succinct answer. 1.87. What is the ratio of the Unemployed and educated male labor force (% of population) of Secondary education in 2002 to that in 2003?
Provide a short and direct response. 0.8. What is the ratio of the Unemployed and educated male labor force (% of population) in Tertiary education in 2002 to that in 2003?
Ensure brevity in your answer.  1.07. What is the ratio of the Unemployed and educated male labor force (% of population) of Primary education in 2002 to that in 2004?
Provide a short and direct response. 1.66. What is the ratio of the Unemployed and educated male labor force (% of population) in Secondary education in 2002 to that in 2004?
Your answer should be very brief. 0.82. What is the ratio of the Unemployed and educated male labor force (% of population) in Tertiary education in 2002 to that in 2004?
Your answer should be compact. 1.88. What is the ratio of the Unemployed and educated male labor force (% of population) in Primary education in 2002 to that in 2005?
Offer a terse response. 1.92. What is the ratio of the Unemployed and educated male labor force (% of population) of Secondary education in 2002 to that in 2005?
Your answer should be very brief. 0.81. What is the ratio of the Unemployed and educated male labor force (% of population) in Tertiary education in 2002 to that in 2005?
Ensure brevity in your answer.  1.93. What is the ratio of the Unemployed and educated male labor force (% of population) of Primary education in 2002 to that in 2006?
Make the answer very short. 1.91. What is the ratio of the Unemployed and educated male labor force (% of population) in Secondary education in 2002 to that in 2006?
Provide a short and direct response. 0.84. What is the ratio of the Unemployed and educated male labor force (% of population) of Tertiary education in 2002 to that in 2006?
Offer a very short reply. 1.01. What is the ratio of the Unemployed and educated male labor force (% of population) in Primary education in 2002 to that in 2011?
Make the answer very short. 0.92. What is the ratio of the Unemployed and educated male labor force (% of population) of Secondary education in 2002 to that in 2011?
Keep it short and to the point. 1.03. What is the ratio of the Unemployed and educated male labor force (% of population) in Tertiary education in 2002 to that in 2011?
Provide a succinct answer. 0.67. What is the ratio of the Unemployed and educated male labor force (% of population) in Primary education in 2003 to that in 2004?
Provide a succinct answer. 0.89. What is the ratio of the Unemployed and educated male labor force (% of population) in Secondary education in 2003 to that in 2004?
Offer a very short reply. 1.02. What is the ratio of the Unemployed and educated male labor force (% of population) in Tertiary education in 2003 to that in 2004?
Your response must be concise. 1.76. What is the ratio of the Unemployed and educated male labor force (% of population) of Primary education in 2003 to that in 2005?
Your answer should be very brief. 1.03. What is the ratio of the Unemployed and educated male labor force (% of population) of Secondary education in 2003 to that in 2005?
Keep it short and to the point. 1.01. What is the ratio of the Unemployed and educated male labor force (% of population) of Tertiary education in 2003 to that in 2005?
Your answer should be very brief. 1.8. What is the ratio of the Unemployed and educated male labor force (% of population) of Primary education in 2003 to that in 2006?
Give a very brief answer. 1.02. What is the ratio of the Unemployed and educated male labor force (% of population) in Secondary education in 2003 to that in 2006?
Offer a terse response. 1.05. What is the ratio of the Unemployed and educated male labor force (% of population) in Primary education in 2003 to that in 2011?
Give a very brief answer. 0.49. What is the ratio of the Unemployed and educated male labor force (% of population) in Secondary education in 2003 to that in 2011?
Offer a very short reply. 1.28. What is the ratio of the Unemployed and educated male labor force (% of population) of Tertiary education in 2003 to that in 2011?
Keep it short and to the point. 0.63. What is the ratio of the Unemployed and educated male labor force (% of population) of Primary education in 2004 to that in 2005?
Your answer should be very brief. 1.16. What is the ratio of the Unemployed and educated male labor force (% of population) of Tertiary education in 2004 to that in 2005?
Provide a short and direct response. 1.02. What is the ratio of the Unemployed and educated male labor force (% of population) of Primary education in 2004 to that in 2006?
Provide a short and direct response. 1.15. What is the ratio of the Unemployed and educated male labor force (% of population) in Secondary education in 2004 to that in 2006?
Make the answer very short. 1.02. What is the ratio of the Unemployed and educated male labor force (% of population) in Tertiary education in 2004 to that in 2006?
Keep it short and to the point. 0.54. What is the ratio of the Unemployed and educated male labor force (% of population) of Primary education in 2004 to that in 2011?
Your response must be concise. 0.55. What is the ratio of the Unemployed and educated male labor force (% of population) in Secondary education in 2004 to that in 2011?
Offer a very short reply. 1.25. What is the ratio of the Unemployed and educated male labor force (% of population) in Tertiary education in 2004 to that in 2011?
Offer a very short reply. 0.36. What is the ratio of the Unemployed and educated male labor force (% of population) of Primary education in 2005 to that in 2006?
Provide a succinct answer. 0.99. What is the ratio of the Unemployed and educated male labor force (% of population) in Secondary education in 2005 to that in 2006?
Your answer should be compact. 1.03. What is the ratio of the Unemployed and educated male labor force (% of population) in Tertiary education in 2005 to that in 2006?
Offer a terse response. 0.53. What is the ratio of the Unemployed and educated male labor force (% of population) of Primary education in 2005 to that in 2011?
Provide a succinct answer. 0.48. What is the ratio of the Unemployed and educated male labor force (% of population) in Secondary education in 2005 to that in 2011?
Your answer should be very brief. 1.27. What is the ratio of the Unemployed and educated male labor force (% of population) of Tertiary education in 2005 to that in 2011?
Provide a succinct answer. 0.35. What is the ratio of the Unemployed and educated male labor force (% of population) in Primary education in 2006 to that in 2011?
Your answer should be very brief. 0.48. What is the ratio of the Unemployed and educated male labor force (% of population) of Secondary education in 2006 to that in 2011?
Keep it short and to the point. 1.23. What is the ratio of the Unemployed and educated male labor force (% of population) in Tertiary education in 2006 to that in 2011?
Ensure brevity in your answer.  0.66. What is the difference between the highest and the second highest Unemployed and educated male labor force (% of population) in Secondary education?
Your response must be concise. 0.9. What is the difference between the highest and the lowest Unemployed and educated male labor force (% of population) of Primary education?
Your response must be concise. 21.8. What is the difference between the highest and the lowest Unemployed and educated male labor force (% of population) in Secondary education?
Your response must be concise. 22.9. What is the difference between the highest and the lowest Unemployed and educated male labor force (% of population) of Tertiary education?
Give a very brief answer. 8.2. 